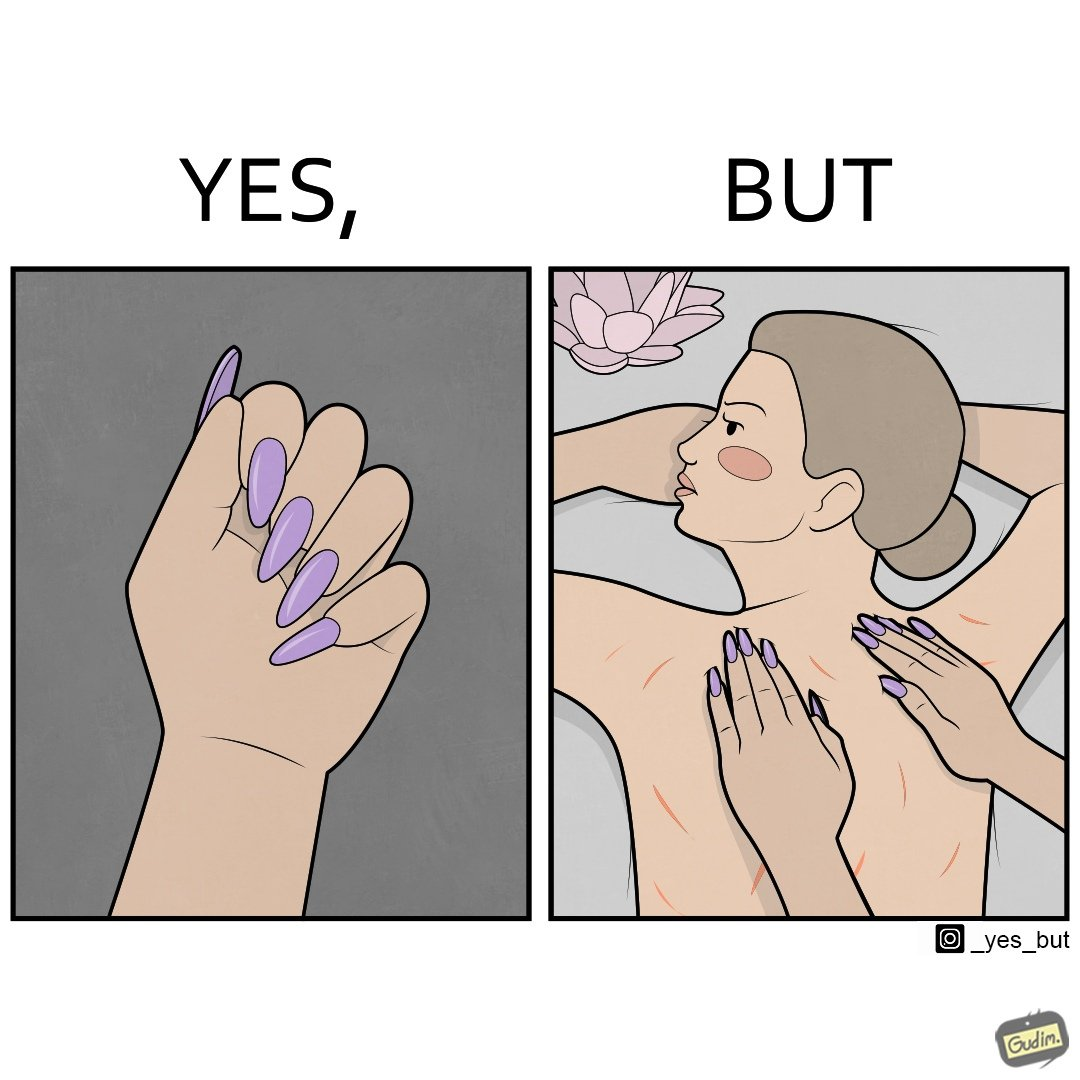Describe the content of this image. The images are funny since it shows that even though the polished and colorful long nails look pretty and fashionable, the hinder the masseuse's ability to do her job of providing relaxing massages and hurts her customers 